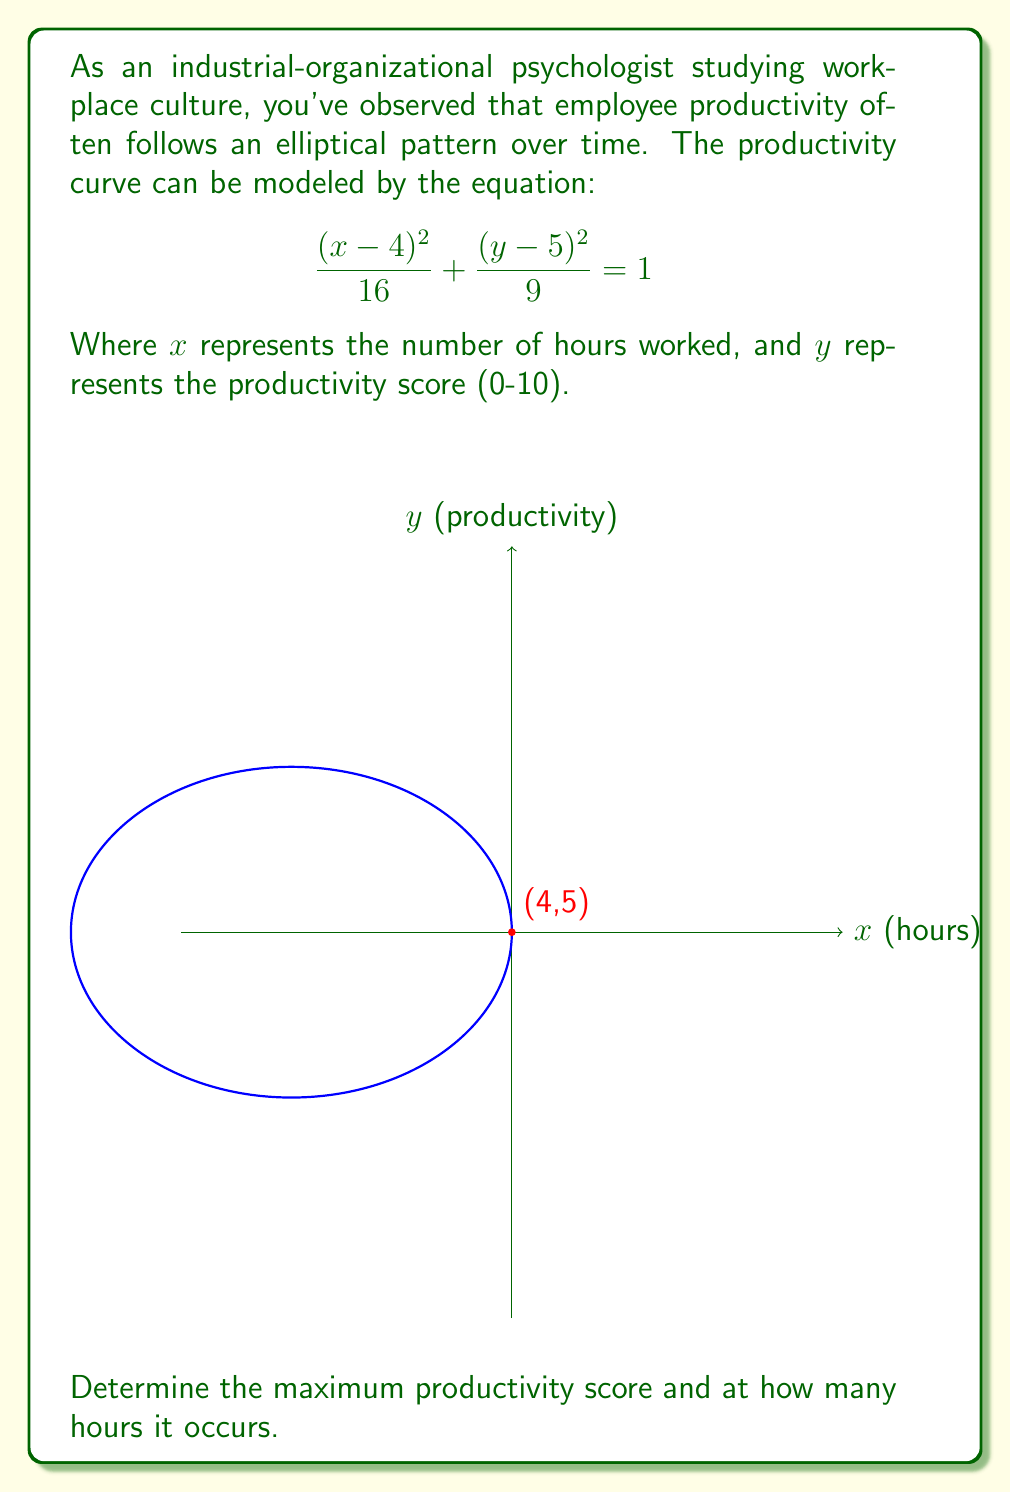Help me with this question. To solve this problem, we'll follow these steps:

1) The general equation of an ellipse is:

   $$\frac{(x-h)^2}{a^2} + \frac{(y-k)^2}{b^2} = 1$$

   Where (h,k) is the center of the ellipse, and a and b are the lengths of the semi-major and semi-minor axes.

2) Comparing our equation to the general form, we can identify:
   h = 4, k = 5, a² = 16, b² = 9

3) The center of the ellipse is at (4,5). This means that the maximum productivity occurs at 4 hours.

4) To find the maximum productivity score, we need to find the y-coordinate of the top point of the ellipse. This will be k + b:

   Maximum y = 5 + √9 = 5 + 3 = 8

Therefore, the maximum productivity score is 8, occurring at 4 hours.
Answer: Maximum productivity score: 8, occurring at 4 hours 